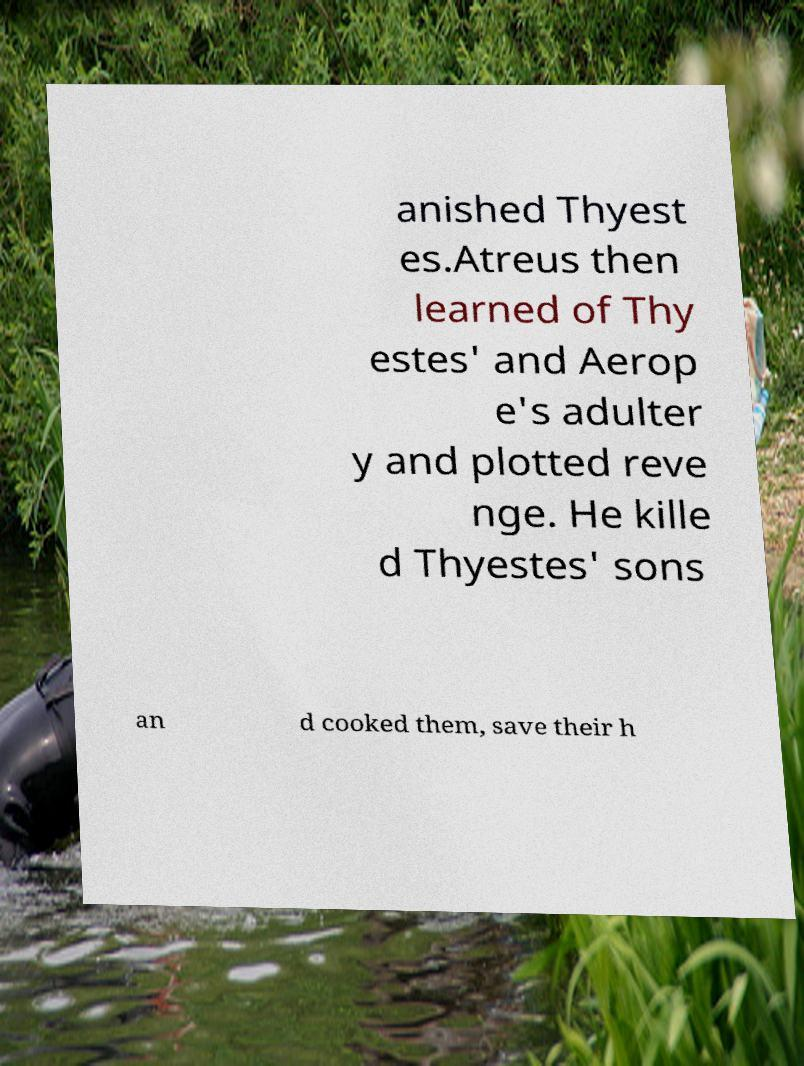For documentation purposes, I need the text within this image transcribed. Could you provide that? anished Thyest es.Atreus then learned of Thy estes' and Aerop e's adulter y and plotted reve nge. He kille d Thyestes' sons an d cooked them, save their h 